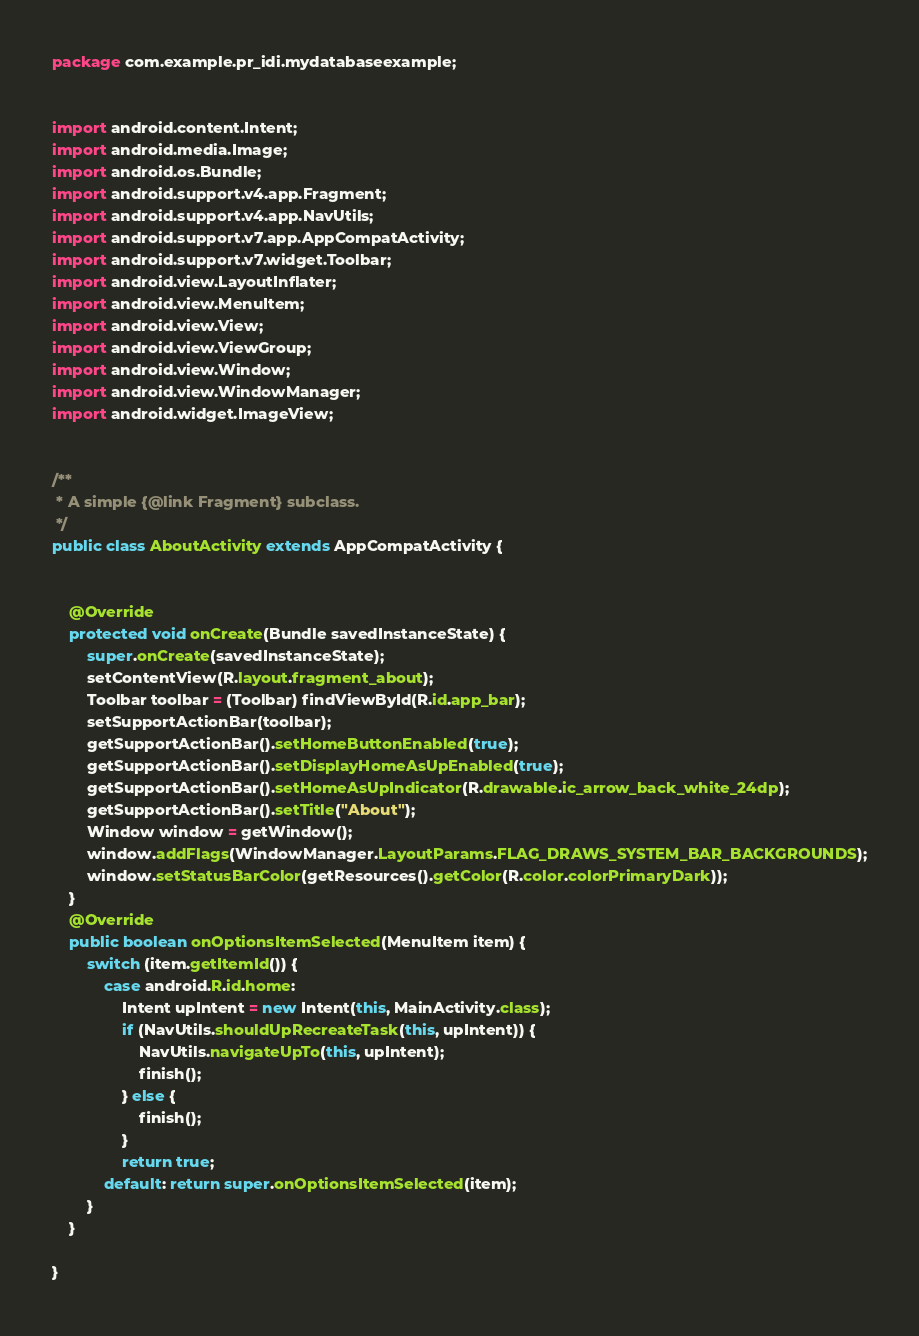Convert code to text. <code><loc_0><loc_0><loc_500><loc_500><_Java_>package com.example.pr_idi.mydatabaseexample;


import android.content.Intent;
import android.media.Image;
import android.os.Bundle;
import android.support.v4.app.Fragment;
import android.support.v4.app.NavUtils;
import android.support.v7.app.AppCompatActivity;
import android.support.v7.widget.Toolbar;
import android.view.LayoutInflater;
import android.view.MenuItem;
import android.view.View;
import android.view.ViewGroup;
import android.view.Window;
import android.view.WindowManager;
import android.widget.ImageView;


/**
 * A simple {@link Fragment} subclass.
 */
public class AboutActivity extends AppCompatActivity {


    @Override
    protected void onCreate(Bundle savedInstanceState) {
        super.onCreate(savedInstanceState);
        setContentView(R.layout.fragment_about);
        Toolbar toolbar = (Toolbar) findViewById(R.id.app_bar);
        setSupportActionBar(toolbar);
        getSupportActionBar().setHomeButtonEnabled(true);
        getSupportActionBar().setDisplayHomeAsUpEnabled(true);
        getSupportActionBar().setHomeAsUpIndicator(R.drawable.ic_arrow_back_white_24dp);
        getSupportActionBar().setTitle("About");
        Window window = getWindow();
        window.addFlags(WindowManager.LayoutParams.FLAG_DRAWS_SYSTEM_BAR_BACKGROUNDS);
        window.setStatusBarColor(getResources().getColor(R.color.colorPrimaryDark));
    }
    @Override
    public boolean onOptionsItemSelected(MenuItem item) {
        switch (item.getItemId()) {
            case android.R.id.home:
                Intent upIntent = new Intent(this, MainActivity.class);
                if (NavUtils.shouldUpRecreateTask(this, upIntent)) {
                    NavUtils.navigateUpTo(this, upIntent);
                    finish();
                } else {
                    finish();
                }
                return true;
            default: return super.onOptionsItemSelected(item);
        }
    }

}
</code> 